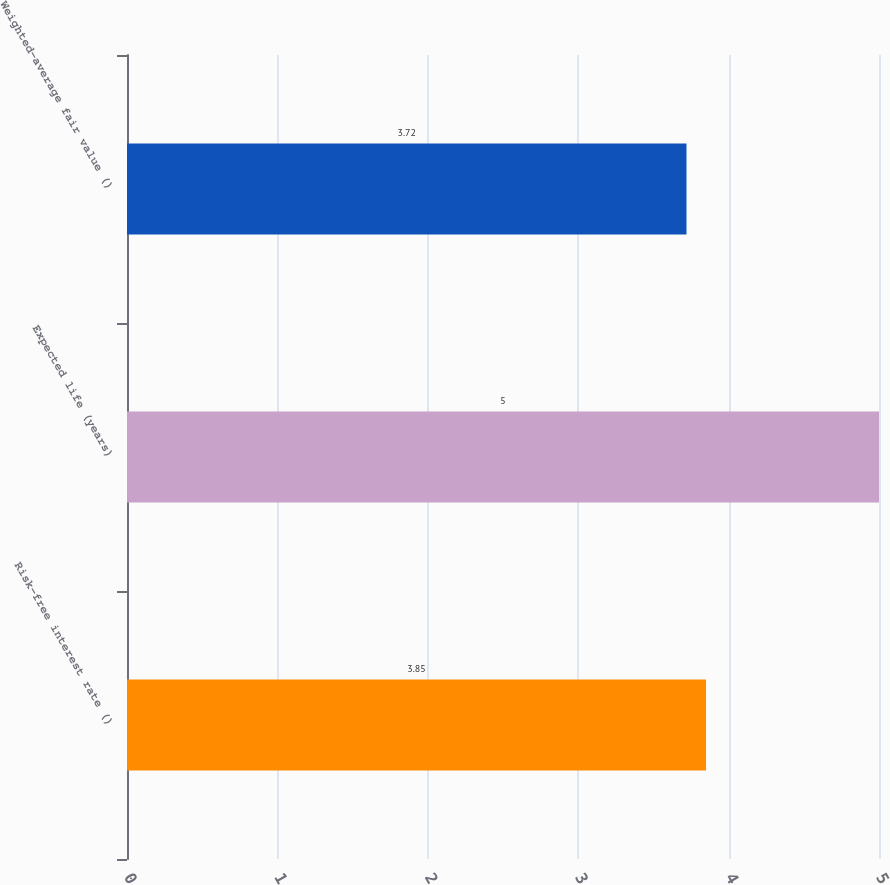Convert chart to OTSL. <chart><loc_0><loc_0><loc_500><loc_500><bar_chart><fcel>Risk-free interest rate ()<fcel>Expected life (years)<fcel>Weighted-average fair value ()<nl><fcel>3.85<fcel>5<fcel>3.72<nl></chart> 